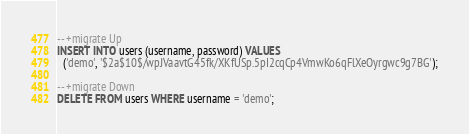Convert code to text. <code><loc_0><loc_0><loc_500><loc_500><_SQL_>-- +migrate Up
INSERT INTO users (username, password) VALUES
  ('demo', '$2a$10$/wpJVaavtG45fk/XKfUSp.5pI2cqCp4VmwKo6qFlXeOyrgwc9g7BG');

-- +migrate Down
DELETE FROM users WHERE username = 'demo';</code> 